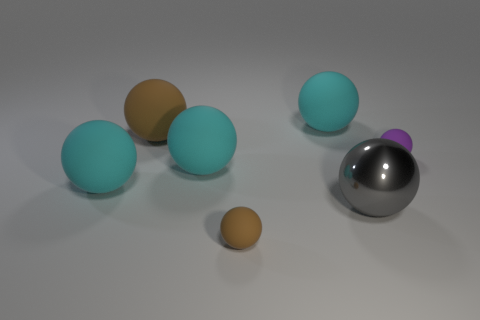Are there any other things that have the same material as the big gray object?
Ensure brevity in your answer.  No. There is a small rubber thing that is behind the big gray metal object; is there a tiny matte ball behind it?
Make the answer very short. No. There is a cyan rubber thing that is behind the large brown object; is its size the same as the brown ball in front of the small purple ball?
Your answer should be very brief. No. How many small objects are either yellow blocks or cyan matte things?
Your answer should be very brief. 0. What material is the cyan sphere that is to the right of the small ball left of the tiny purple object?
Offer a terse response. Rubber. Are there any brown spheres that have the same material as the gray ball?
Give a very brief answer. No. Do the purple thing and the big sphere left of the large brown object have the same material?
Your response must be concise. Yes. There is another rubber sphere that is the same size as the purple matte sphere; what is its color?
Your answer should be very brief. Brown. There is a brown matte ball behind the brown object right of the big brown ball; what size is it?
Make the answer very short. Large. Do the shiny ball and the small ball on the left side of the big gray thing have the same color?
Ensure brevity in your answer.  No. 